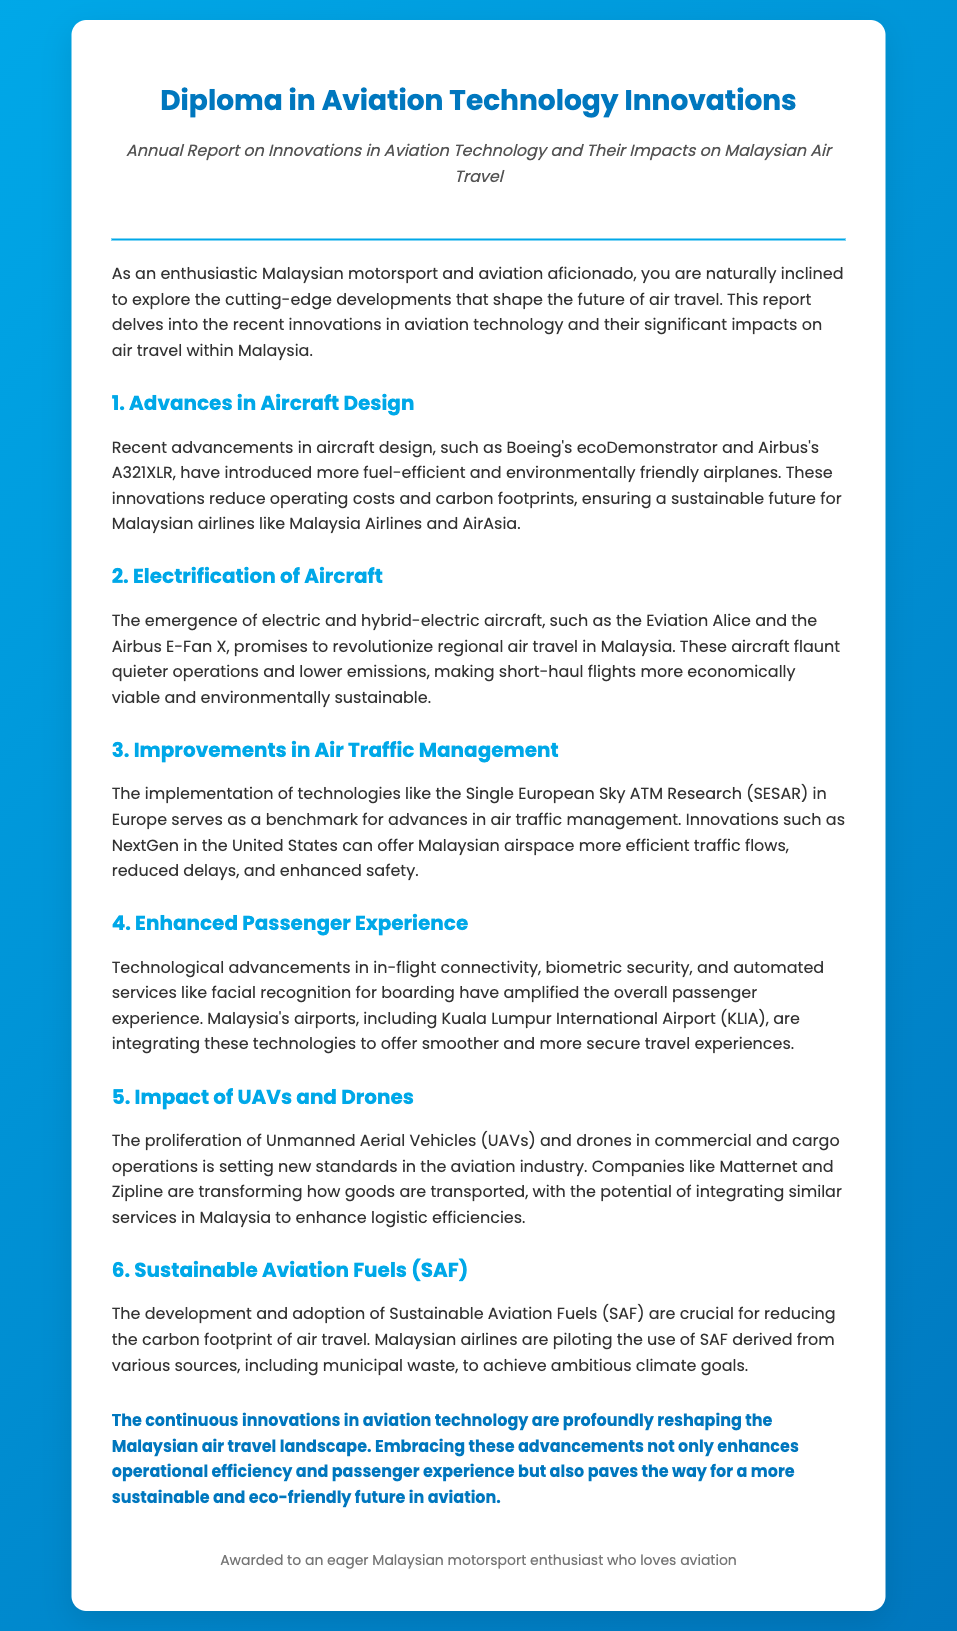what is the title of the document? The title of the document is stated prominently at the top of the report, indicating its focus on aviation technology innovations.
Answer: Diploma in Aviation Technology Innovations which airline is mentioned as a pilot for Sustainable Aviation Fuels? The document states that Malaysian airlines are piloting the use of Sustainable Aviation Fuels derived from various sources.
Answer: Malaysian airlines what is the primary benefit of electric and hybrid-electric aircraft? The document highlights that these aircraft promise to revolutionize regional air travel with quieter operations and lower emissions.
Answer: Quieter operations and lower emissions how does the report describe innovations in aircraft design? The report states that advancements like Boeing's ecoDemonstrator and Airbus's A321XLR reduce operating costs and carbon footprints.
Answer: Reduce operating costs and carbon footprints what airport is mentioned regarding enhanced passenger experience technologies? The report specifically mentions Kuala Lumpur International Airport in the context of integrating new technologies for passenger experience.
Answer: Kuala Lumpur International Airport what is the conclusion regarding innovations in aviation technology? The conclusion summarizes that continuous innovations in aviation technology are reshaping the Malaysian air travel landscape.
Answer: Reshaping the Malaysian air travel landscape 